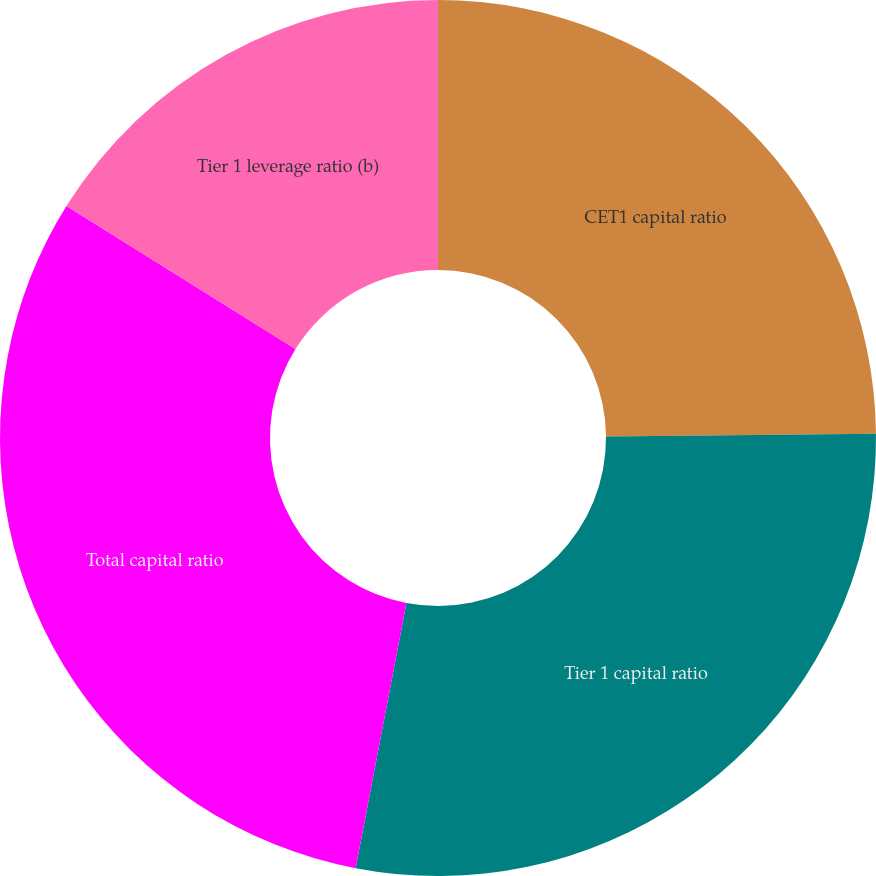Convert chart. <chart><loc_0><loc_0><loc_500><loc_500><pie_chart><fcel>CET1 capital ratio<fcel>Tier 1 capital ratio<fcel>Total capital ratio<fcel>Tier 1 leverage ratio (b)<nl><fcel>24.85%<fcel>28.16%<fcel>30.87%<fcel>16.12%<nl></chart> 